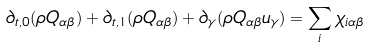Convert formula to latex. <formula><loc_0><loc_0><loc_500><loc_500>\partial _ { t , 0 } ( \rho Q _ { \alpha \beta } ) + \partial _ { t , 1 } ( \rho Q _ { \alpha \beta } ) + \partial _ { \gamma } ( \rho Q _ { \alpha \beta } u _ { \gamma } ) = \sum _ { i } \chi _ { i \alpha \beta }</formula> 